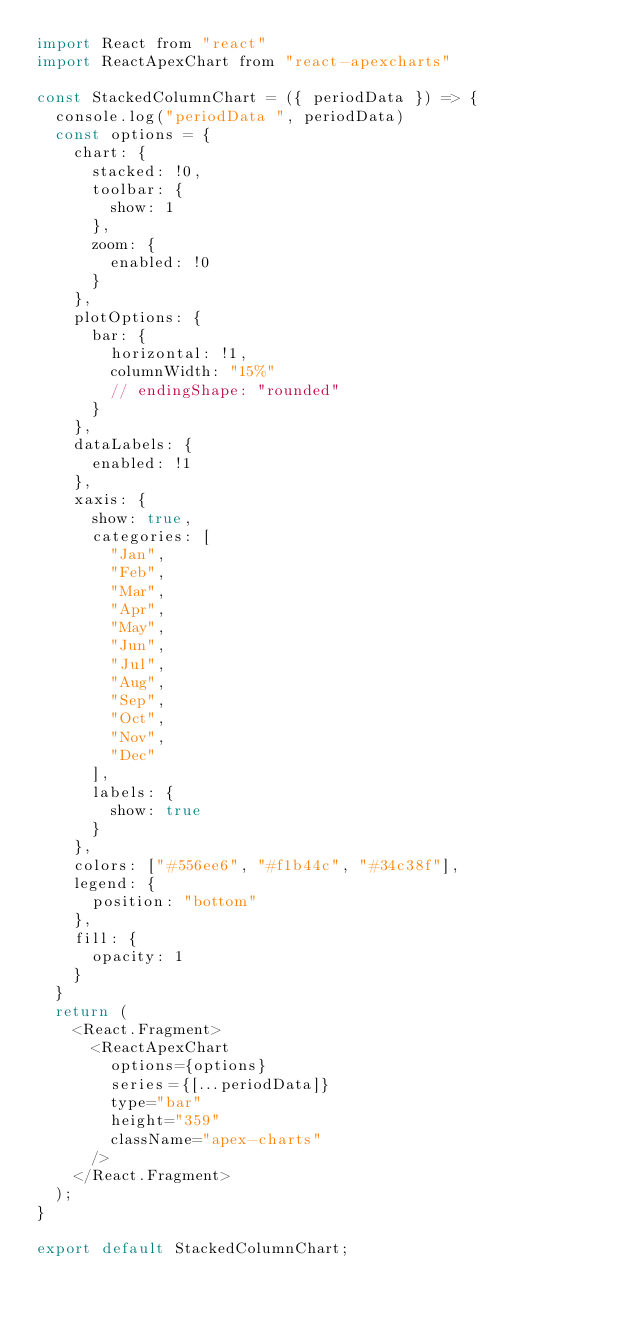Convert code to text. <code><loc_0><loc_0><loc_500><loc_500><_JavaScript_>import React from "react"
import ReactApexChart from "react-apexcharts"

const StackedColumnChart = ({ periodData }) => {
  console.log("periodData ", periodData)
  const options = {
    chart: {
      stacked: !0,
      toolbar: {
        show: 1
      },
      zoom: {
        enabled: !0
      }
    },
    plotOptions: {
      bar: {
        horizontal: !1,
        columnWidth: "15%"
        // endingShape: "rounded"
      }
    },
    dataLabels: {
      enabled: !1
    },
    xaxis: {
      show: true,
      categories: [
        "Jan",
        "Feb",
        "Mar",
        "Apr",
        "May",
        "Jun",
        "Jul",
        "Aug",
        "Sep",
        "Oct",
        "Nov",
        "Dec"
      ],
      labels: {
        show: true
      }
    },
    colors: ["#556ee6", "#f1b44c", "#34c38f"],
    legend: {
      position: "bottom"
    },
    fill: {
      opacity: 1
    }
  }
  return (
    <React.Fragment>
      <ReactApexChart
        options={options}
        series={[...periodData]}
        type="bar"
        height="359"
        className="apex-charts"
      />
    </React.Fragment>
  );
}

export default StackedColumnChart;
</code> 